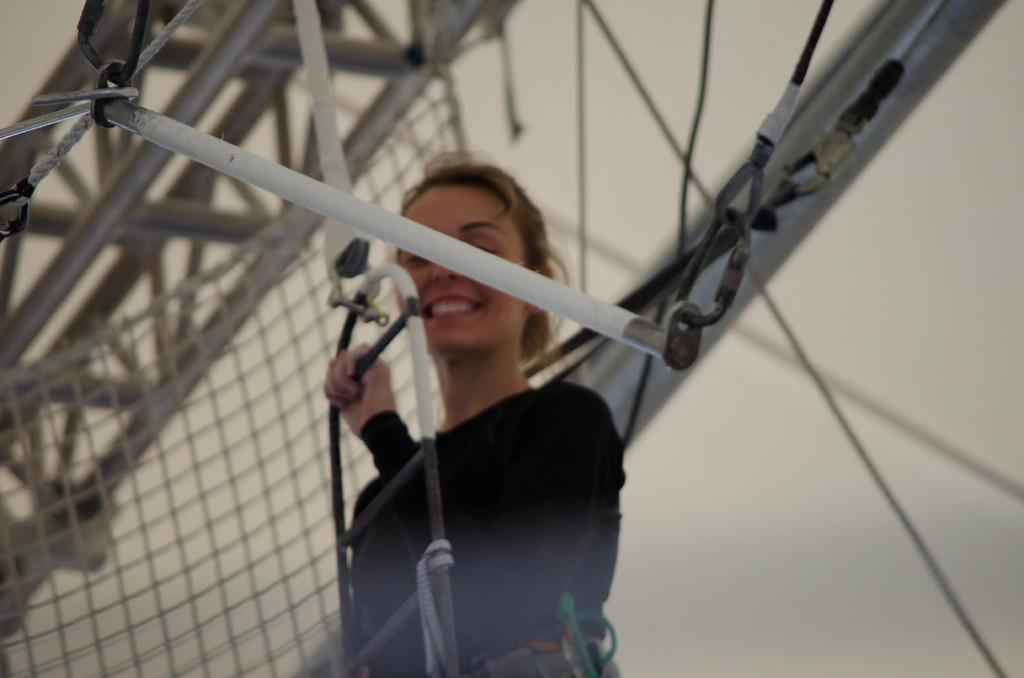What is the person in the image doing? The person is standing in the image and holding an object. Can you describe the object the person is holding? The facts do not specify the object the person is holding. What other items can be seen in the image besides the person? There are rods and a net in the image. What is visible in the background of the image? There is a wall visible in the background of the image. What type of lipstick is the person wearing in the image? There is no mention of lipstick or any cosmetic items in the image. 